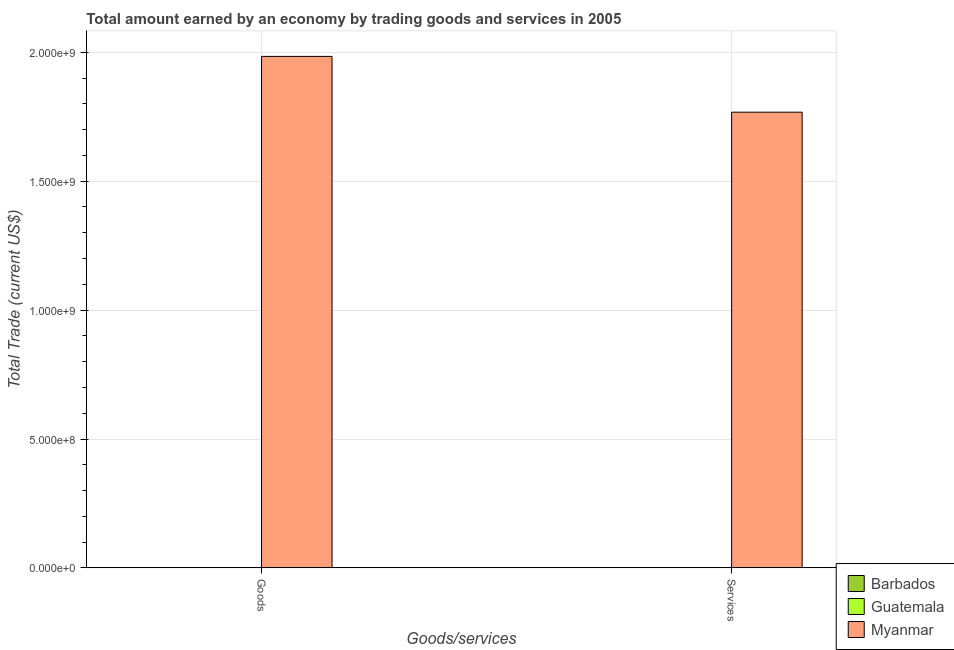How many bars are there on the 1st tick from the left?
Provide a short and direct response. 1. What is the label of the 2nd group of bars from the left?
Provide a short and direct response. Services. What is the amount earned by trading services in Myanmar?
Make the answer very short. 1.77e+09. Across all countries, what is the maximum amount earned by trading services?
Provide a succinct answer. 1.77e+09. Across all countries, what is the minimum amount earned by trading goods?
Offer a terse response. 0. In which country was the amount earned by trading services maximum?
Your answer should be very brief. Myanmar. What is the total amount earned by trading goods in the graph?
Keep it short and to the point. 1.98e+09. What is the difference between the amount earned by trading goods in Guatemala and the amount earned by trading services in Myanmar?
Provide a short and direct response. -1.77e+09. What is the average amount earned by trading services per country?
Offer a very short reply. 5.89e+08. What is the difference between the amount earned by trading services and amount earned by trading goods in Myanmar?
Offer a terse response. -2.16e+08. How many bars are there?
Your answer should be compact. 2. Are all the bars in the graph horizontal?
Your response must be concise. No. What is the difference between two consecutive major ticks on the Y-axis?
Your response must be concise. 5.00e+08. Are the values on the major ticks of Y-axis written in scientific E-notation?
Offer a very short reply. Yes. How many legend labels are there?
Your response must be concise. 3. How are the legend labels stacked?
Ensure brevity in your answer.  Vertical. What is the title of the graph?
Provide a short and direct response. Total amount earned by an economy by trading goods and services in 2005. Does "Papua New Guinea" appear as one of the legend labels in the graph?
Your response must be concise. No. What is the label or title of the X-axis?
Make the answer very short. Goods/services. What is the label or title of the Y-axis?
Offer a terse response. Total Trade (current US$). What is the Total Trade (current US$) of Myanmar in Goods?
Keep it short and to the point. 1.98e+09. What is the Total Trade (current US$) of Barbados in Services?
Give a very brief answer. 0. What is the Total Trade (current US$) in Myanmar in Services?
Give a very brief answer. 1.77e+09. Across all Goods/services, what is the maximum Total Trade (current US$) of Myanmar?
Give a very brief answer. 1.98e+09. Across all Goods/services, what is the minimum Total Trade (current US$) in Myanmar?
Keep it short and to the point. 1.77e+09. What is the total Total Trade (current US$) of Barbados in the graph?
Offer a very short reply. 0. What is the total Total Trade (current US$) of Myanmar in the graph?
Ensure brevity in your answer.  3.75e+09. What is the difference between the Total Trade (current US$) of Myanmar in Goods and that in Services?
Provide a succinct answer. 2.16e+08. What is the average Total Trade (current US$) of Myanmar per Goods/services?
Your answer should be very brief. 1.88e+09. What is the ratio of the Total Trade (current US$) of Myanmar in Goods to that in Services?
Your answer should be very brief. 1.12. What is the difference between the highest and the second highest Total Trade (current US$) of Myanmar?
Your response must be concise. 2.16e+08. What is the difference between the highest and the lowest Total Trade (current US$) in Myanmar?
Your response must be concise. 2.16e+08. 